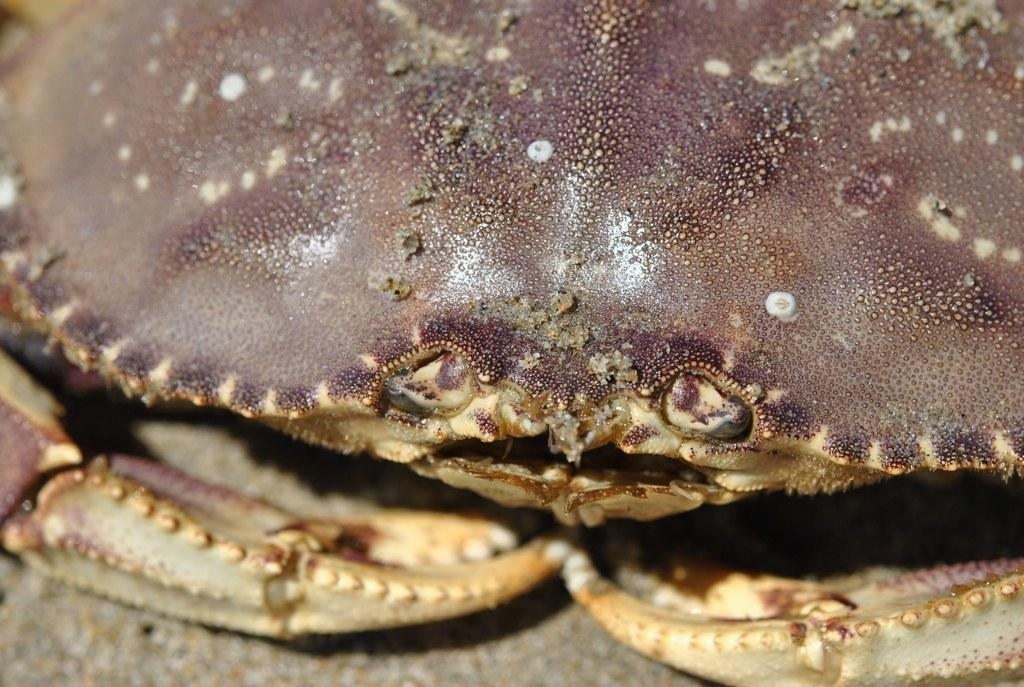What type of animal is present in the image? There is a crab in the image. How many chairs are visible in the image? There are no chairs present in the image, as it only features a crab. Is there any magic happening in the image? There is no magic present in the image, as it only features a crab. 